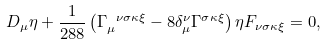<formula> <loc_0><loc_0><loc_500><loc_500>D _ { \mu } \eta + \frac { 1 } { 2 8 8 } \left ( \Gamma _ { \mu } ^ { \ \nu \sigma \kappa \xi } - 8 \delta _ { \mu } ^ { \nu } \Gamma ^ { \sigma \kappa \xi } \right ) \eta F _ { \nu \sigma \kappa \xi } = 0 ,</formula> 